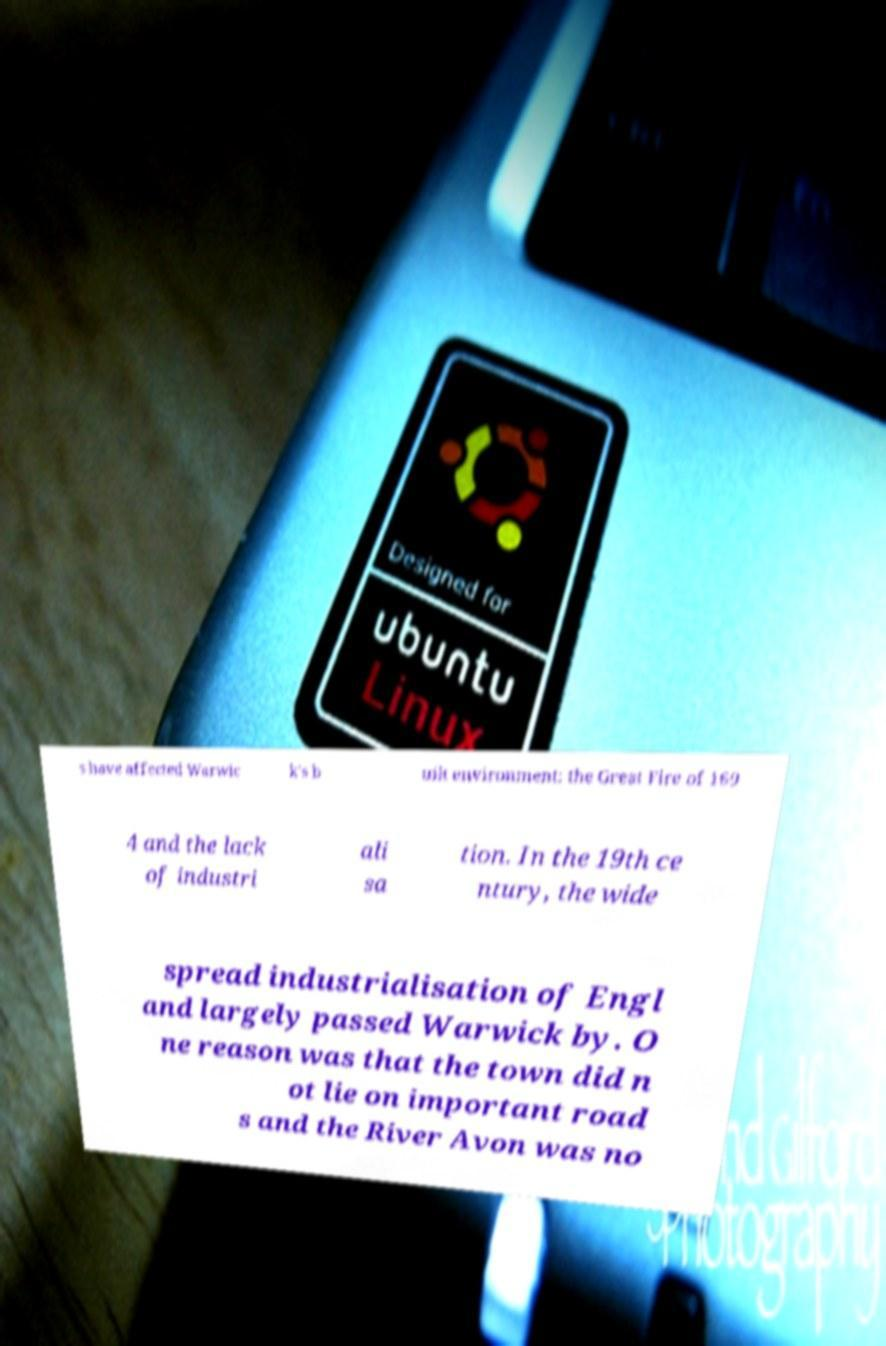Can you accurately transcribe the text from the provided image for me? s have affected Warwic k's b uilt environment: the Great Fire of 169 4 and the lack of industri ali sa tion. In the 19th ce ntury, the wide spread industrialisation of Engl and largely passed Warwick by. O ne reason was that the town did n ot lie on important road s and the River Avon was no 